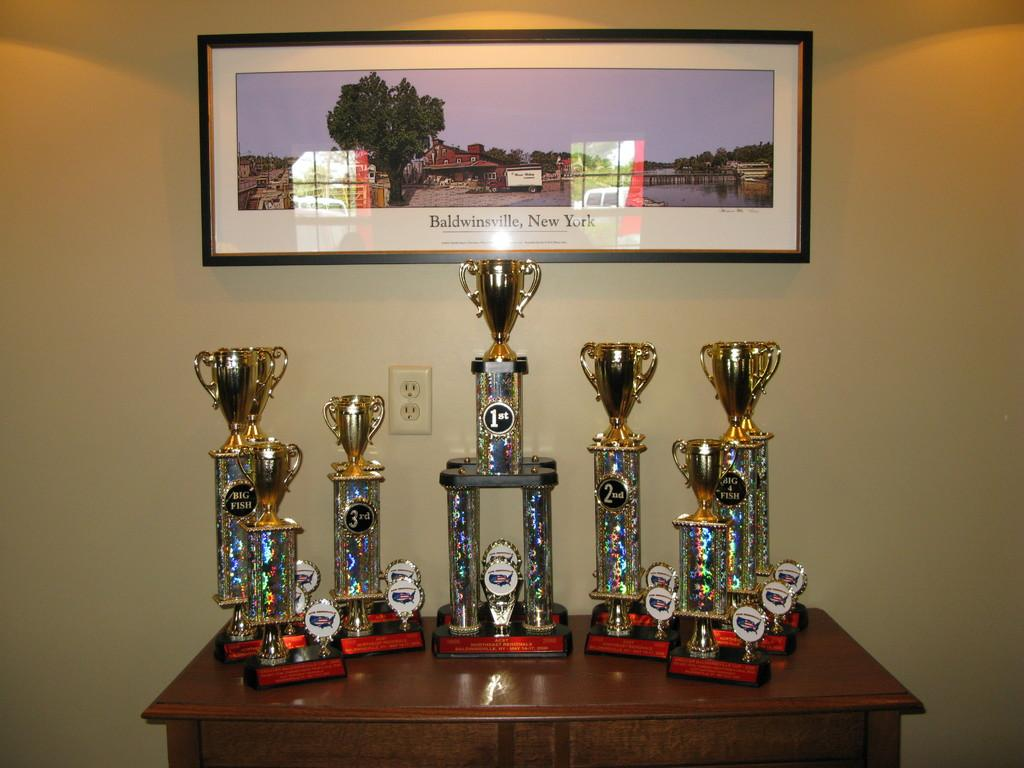<image>
Provide a brief description of the given image. Seven large golden cup trophies sitting a oak cabinet . 